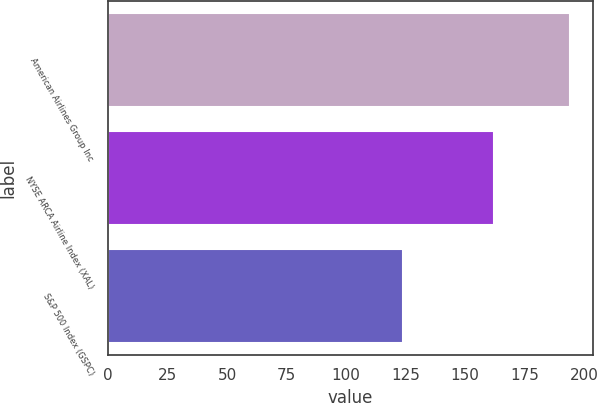Convert chart to OTSL. <chart><loc_0><loc_0><loc_500><loc_500><bar_chart><fcel>American Airlines Group Inc<fcel>NYSE ARCA Airline Index (XAL)<fcel>S&P 500 Index (GSPC)<nl><fcel>194<fcel>162<fcel>124<nl></chart> 